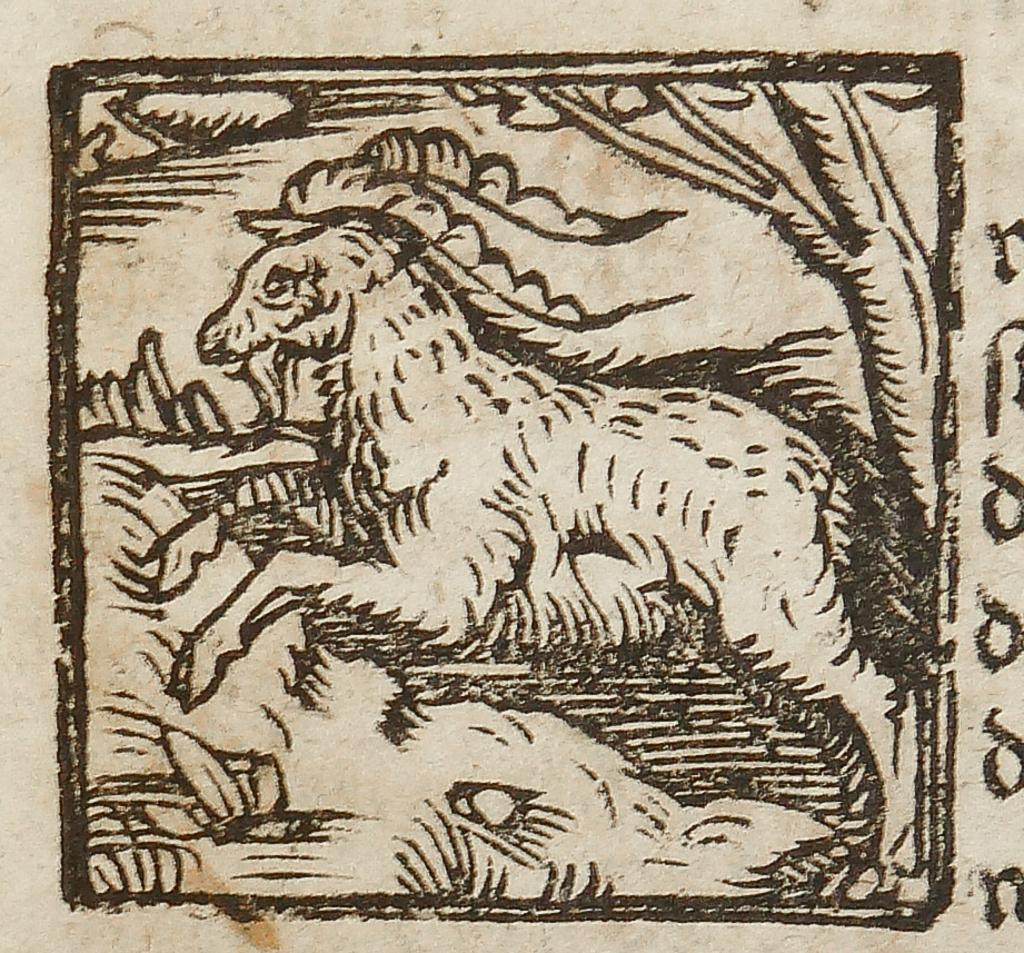What is depicted in the drawing in the image? There is a drawing of a horse in the image. What type of vegetation can be seen in the image? There are leaves and a tree in the image. Where is the text located in the image? The text is on the right side of the image. What shape is the quiver in the image? There is no quiver present in the image. What process is being depicted in the drawing of the horse? The drawing of the horse is a static image and does not depict a process. 